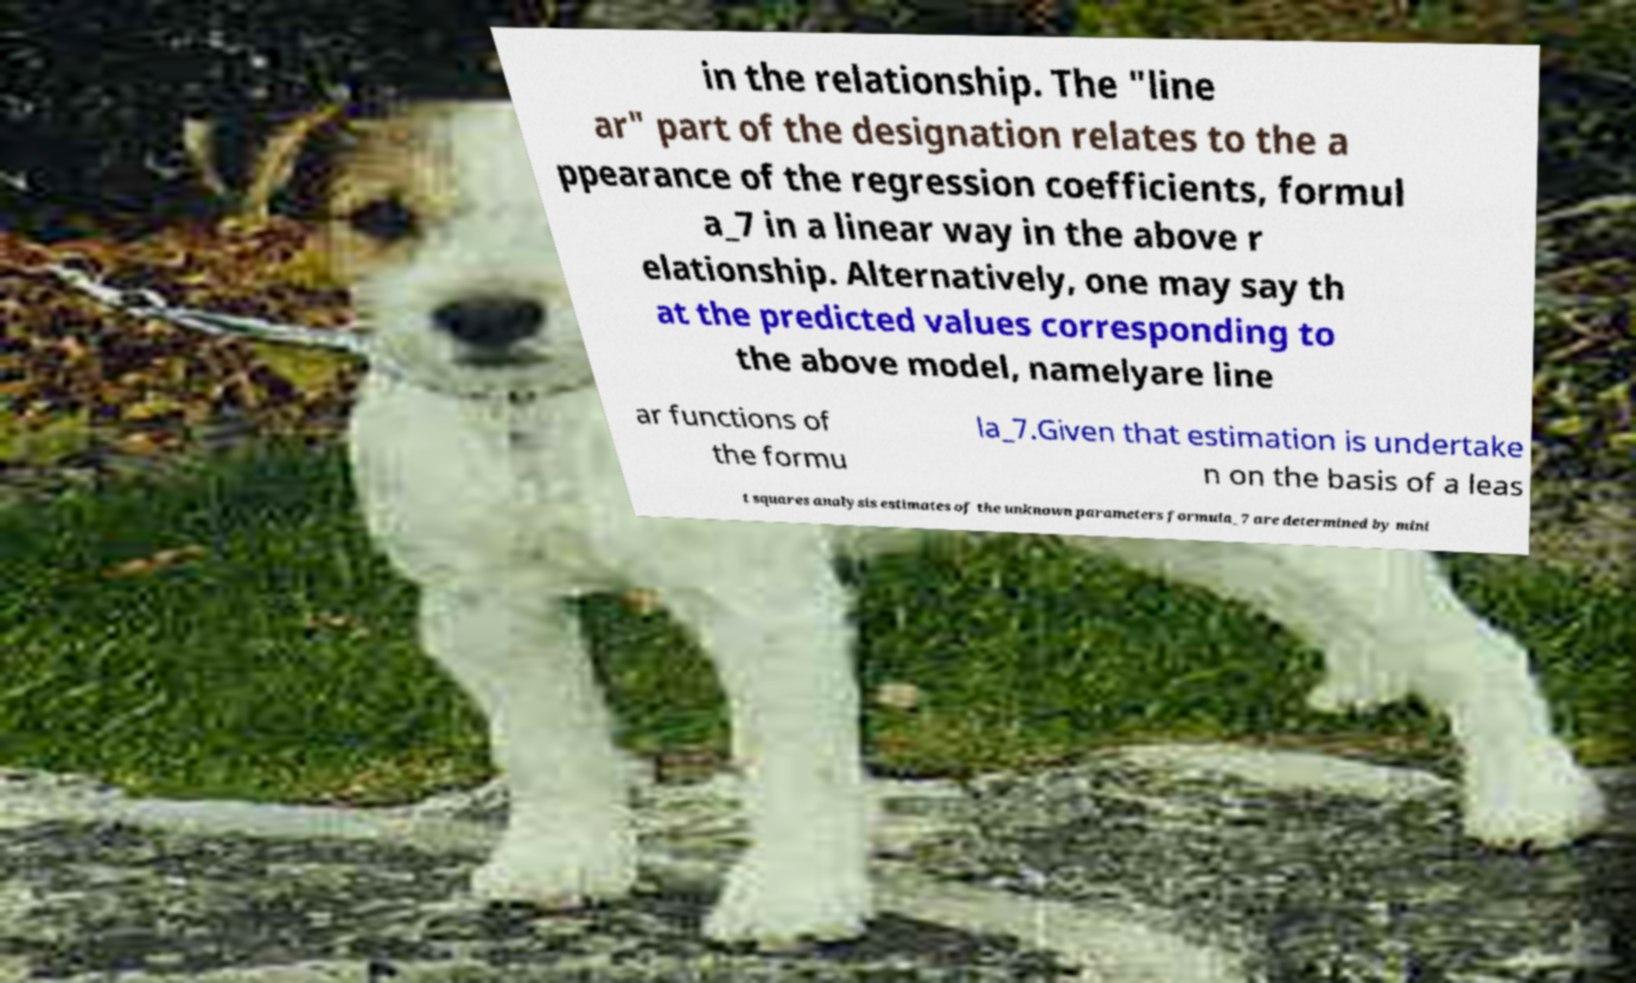Could you extract and type out the text from this image? in the relationship. The "line ar" part of the designation relates to the a ppearance of the regression coefficients, formul a_7 in a linear way in the above r elationship. Alternatively, one may say th at the predicted values corresponding to the above model, namelyare line ar functions of the formu la_7.Given that estimation is undertake n on the basis of a leas t squares analysis estimates of the unknown parameters formula_7 are determined by mini 